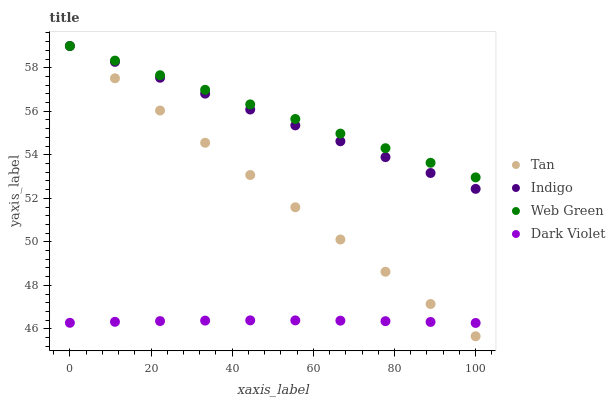Does Dark Violet have the minimum area under the curve?
Answer yes or no. Yes. Does Web Green have the maximum area under the curve?
Answer yes or no. Yes. Does Indigo have the minimum area under the curve?
Answer yes or no. No. Does Indigo have the maximum area under the curve?
Answer yes or no. No. Is Tan the smoothest?
Answer yes or no. Yes. Is Dark Violet the roughest?
Answer yes or no. Yes. Is Indigo the smoothest?
Answer yes or no. No. Is Indigo the roughest?
Answer yes or no. No. Does Tan have the lowest value?
Answer yes or no. Yes. Does Indigo have the lowest value?
Answer yes or no. No. Does Web Green have the highest value?
Answer yes or no. Yes. Does Dark Violet have the highest value?
Answer yes or no. No. Is Dark Violet less than Web Green?
Answer yes or no. Yes. Is Indigo greater than Dark Violet?
Answer yes or no. Yes. Does Web Green intersect Indigo?
Answer yes or no. Yes. Is Web Green less than Indigo?
Answer yes or no. No. Is Web Green greater than Indigo?
Answer yes or no. No. Does Dark Violet intersect Web Green?
Answer yes or no. No. 